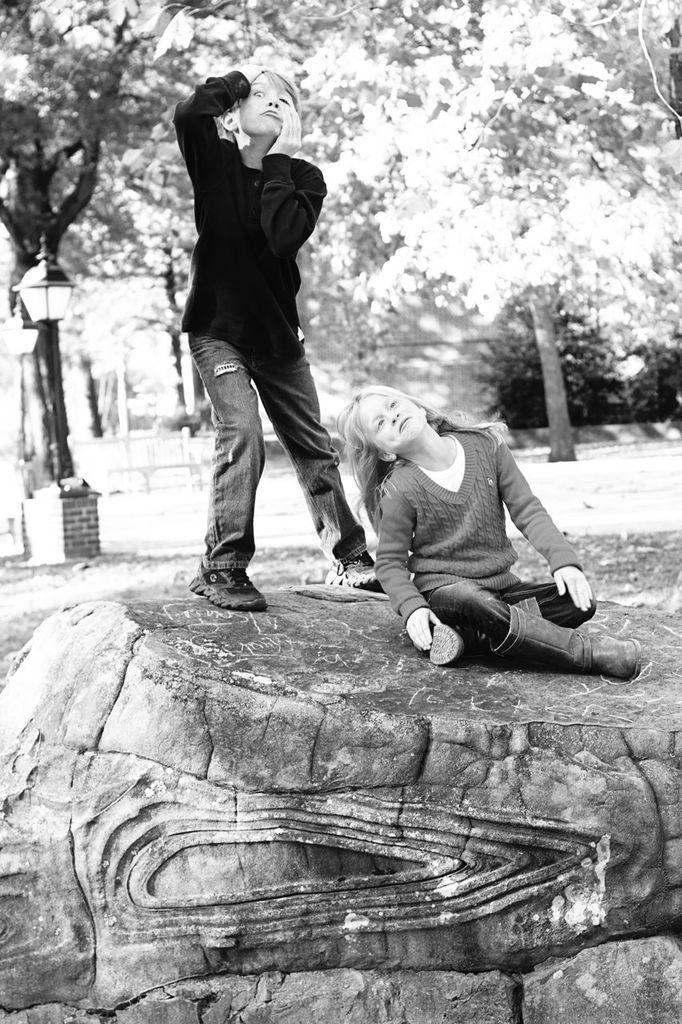What is the color scheme of the image? The image is black and white. How many kids are in the image? There are two kids in the image. Where are the kids located in the image? The kids are on a path in the image. What can be seen behind the kids in the image? There are trees visible behind the kids in the image. What else can be seen in the background of the image? There are other unspecified items visible in the background. What action is the daughter performing in the image? There is no daughter present in the image, and therefore no action can be attributed to her. 